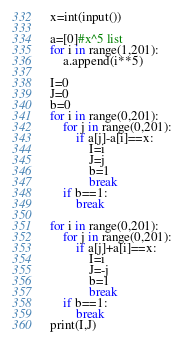Convert code to text. <code><loc_0><loc_0><loc_500><loc_500><_Python_>x=int(input())

a=[0]#x^5 list
for i in range(1,201):
    a.append(i**5)

I=0
J=0
b=0
for i in range(0,201):
    for j in range(0,201):
        if a[j]-a[i]==x:
            I=i
            J=j
            b=1
            break
    if b==1:
        break

for i in range(0,201):
    for j in range(0,201):
        if a[j]+a[i]==x:
            I=i
            J=-j
            b=1
            break
    if b==1:
        break
print(I,J)</code> 